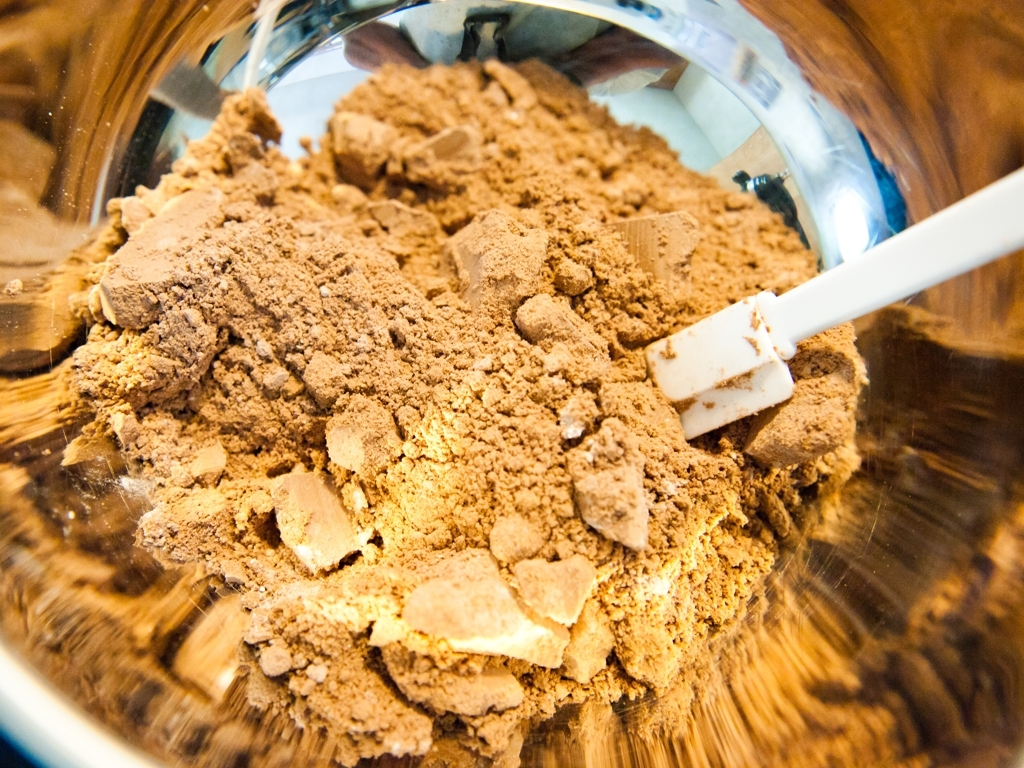What does the texture of the powder tell you? The powder's texture is coarse with visible lumps, indicating that it's not finely milled. This could affect how it dissolves or blends into other ingredients and might suggest that the powder is meant to be used in recipes where a finer texture isn't essential, or that it may need further processing before use. 